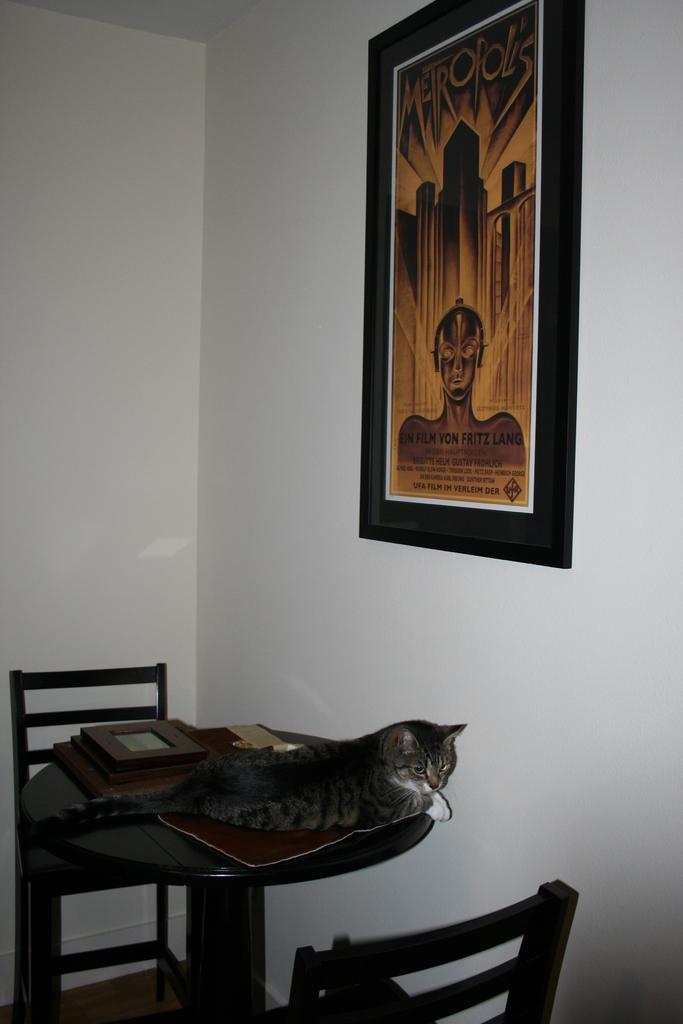How would you summarize this image in a sentence or two? This is a picture in a room, the cat is sitting on the table. This are the chairs and background of the table there is a wall on the wall there is a photo frame. 